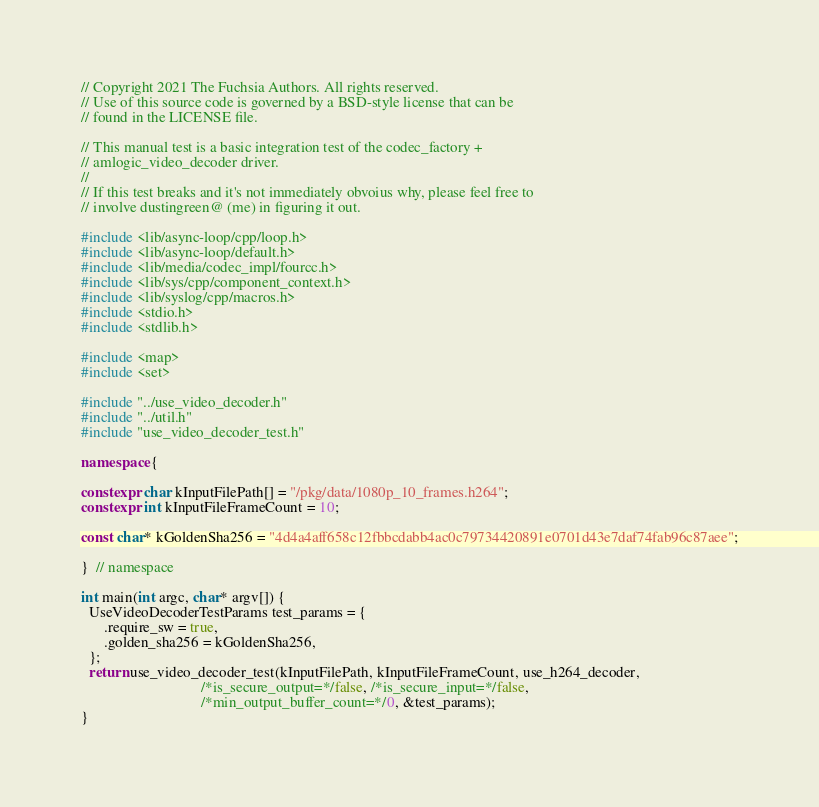Convert code to text. <code><loc_0><loc_0><loc_500><loc_500><_C++_>// Copyright 2021 The Fuchsia Authors. All rights reserved.
// Use of this source code is governed by a BSD-style license that can be
// found in the LICENSE file.

// This manual test is a basic integration test of the codec_factory +
// amlogic_video_decoder driver.
//
// If this test breaks and it's not immediately obvoius why, please feel free to
// involve dustingreen@ (me) in figuring it out.

#include <lib/async-loop/cpp/loop.h>
#include <lib/async-loop/default.h>
#include <lib/media/codec_impl/fourcc.h>
#include <lib/sys/cpp/component_context.h>
#include <lib/syslog/cpp/macros.h>
#include <stdio.h>
#include <stdlib.h>

#include <map>
#include <set>

#include "../use_video_decoder.h"
#include "../util.h"
#include "use_video_decoder_test.h"

namespace {

constexpr char kInputFilePath[] = "/pkg/data/1080p_10_frames.h264";
constexpr int kInputFileFrameCount = 10;

const char* kGoldenSha256 = "4d4a4aff658c12fbbcdabb4ac0c79734420891e0701d43e7daf74fab96c87aee";

}  // namespace

int main(int argc, char* argv[]) {
  UseVideoDecoderTestParams test_params = {
      .require_sw = true,
      .golden_sha256 = kGoldenSha256,
  };
  return use_video_decoder_test(kInputFilePath, kInputFileFrameCount, use_h264_decoder,
                                /*is_secure_output=*/false, /*is_secure_input=*/false,
                                /*min_output_buffer_count=*/0, &test_params);
}
</code> 